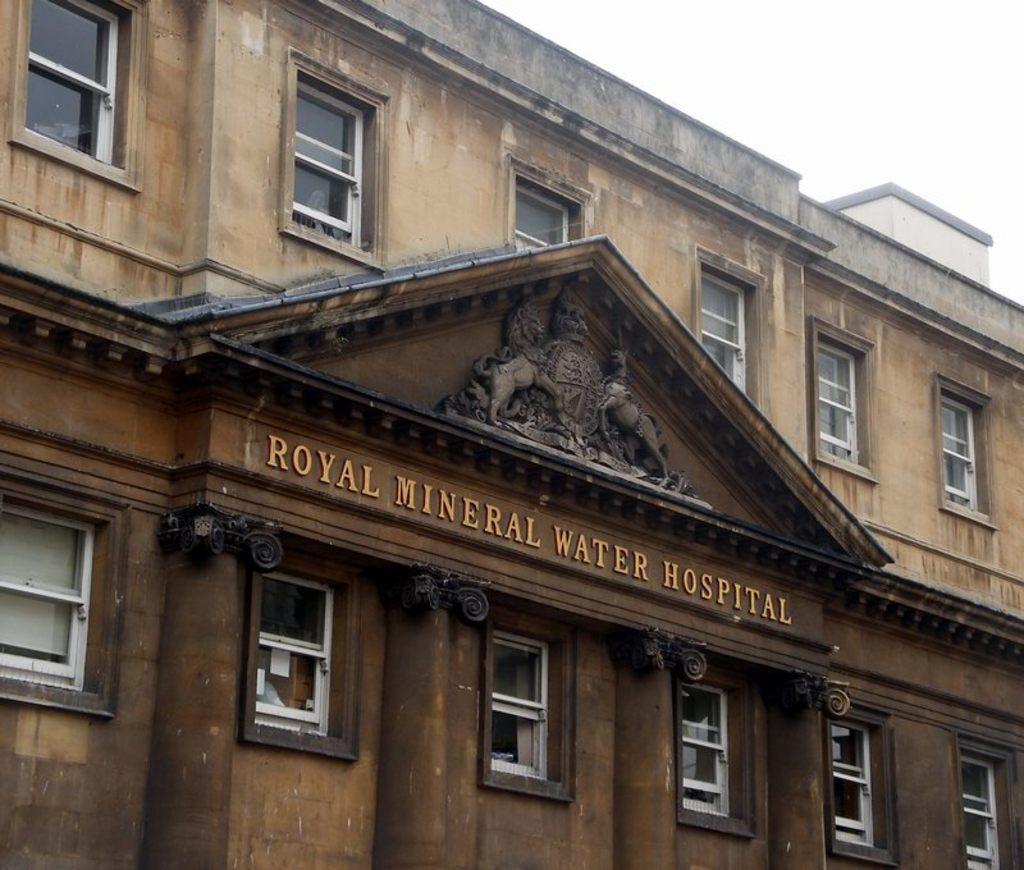What is the main structure visible in the image? There is a building in the image. Can you describe any additional features of the building? There is text on the building. What type of food is being stored in the pocket of the building in the image? There is no pocket or food present in the image; it features a building with text on it. 